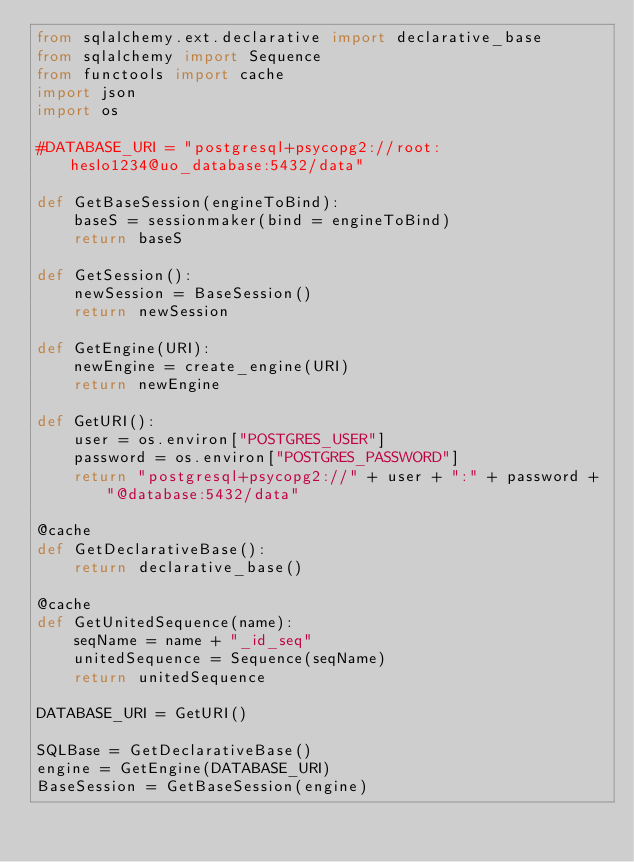Convert code to text. <code><loc_0><loc_0><loc_500><loc_500><_Python_>from sqlalchemy.ext.declarative import declarative_base
from sqlalchemy import Sequence
from functools import cache
import json
import os

#DATABASE_URI = "postgresql+psycopg2://root:heslo1234@uo_database:5432/data"

def GetBaseSession(engineToBind):
    baseS = sessionmaker(bind = engineToBind)
    return baseS

def GetSession():
    newSession = BaseSession()
    return newSession

def GetEngine(URI):
    newEngine = create_engine(URI)
    return newEngine

def GetURI():
    user = os.environ["POSTGRES_USER"]
    password = os.environ["POSTGRES_PASSWORD"]
    return "postgresql+psycopg2://" + user + ":" + password + "@database:5432/data"

@cache
def GetDeclarativeBase():
    return declarative_base()

@cache
def GetUnitedSequence(name):
    seqName = name + "_id_seq"
    unitedSequence = Sequence(seqName)
    return unitedSequence

DATABASE_URI = GetURI()

SQLBase = GetDeclarativeBase()
engine = GetEngine(DATABASE_URI)
BaseSession = GetBaseSession(engine)</code> 